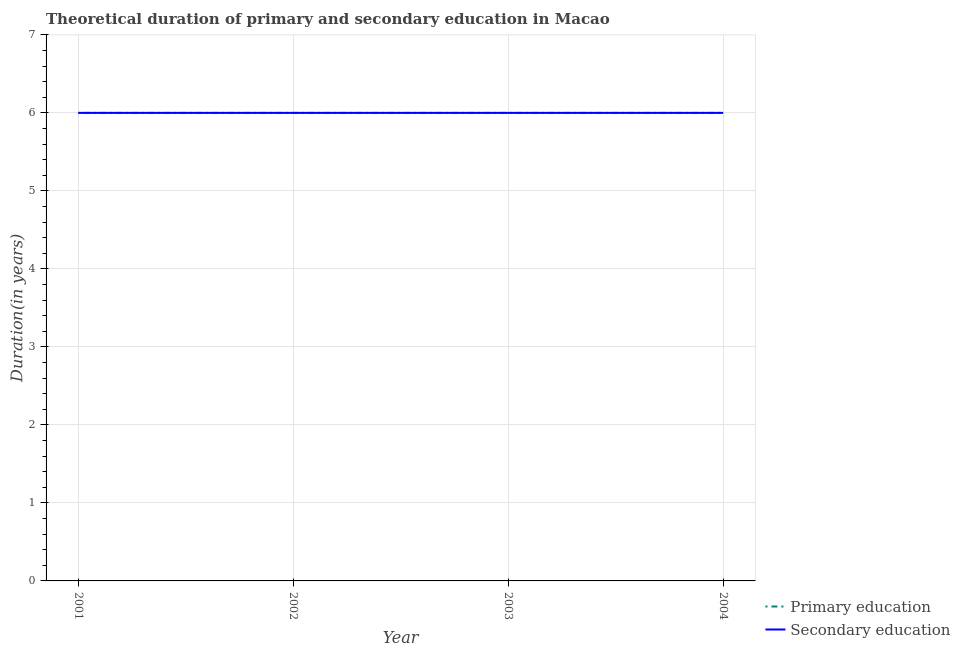How many different coloured lines are there?
Your response must be concise. 2. Does the line corresponding to duration of primary education intersect with the line corresponding to duration of secondary education?
Provide a succinct answer. Yes. What is the duration of primary education in 2003?
Ensure brevity in your answer.  6. Across all years, what is the minimum duration of primary education?
Give a very brief answer. 6. In which year was the duration of secondary education maximum?
Provide a short and direct response. 2001. What is the total duration of secondary education in the graph?
Your response must be concise. 24. What is the difference between the duration of secondary education in 2001 and that in 2003?
Make the answer very short. 0. What is the difference between the duration of primary education in 2004 and the duration of secondary education in 2001?
Offer a terse response. 0. What is the average duration of primary education per year?
Give a very brief answer. 6. In the year 2001, what is the difference between the duration of primary education and duration of secondary education?
Make the answer very short. 0. In how many years, is the duration of secondary education greater than 2.4 years?
Make the answer very short. 4. Is the duration of primary education in 2002 less than that in 2003?
Give a very brief answer. No. What is the difference between the highest and the lowest duration of secondary education?
Offer a very short reply. 0. In how many years, is the duration of secondary education greater than the average duration of secondary education taken over all years?
Your response must be concise. 0. Is the sum of the duration of secondary education in 2002 and 2003 greater than the maximum duration of primary education across all years?
Offer a very short reply. Yes. What is the difference between two consecutive major ticks on the Y-axis?
Your answer should be very brief. 1. Does the graph contain grids?
Provide a short and direct response. Yes. How many legend labels are there?
Offer a terse response. 2. What is the title of the graph?
Keep it short and to the point. Theoretical duration of primary and secondary education in Macao. What is the label or title of the Y-axis?
Give a very brief answer. Duration(in years). What is the Duration(in years) in Primary education in 2001?
Your response must be concise. 6. What is the Duration(in years) of Primary education in 2002?
Make the answer very short. 6. What is the Duration(in years) of Primary education in 2003?
Ensure brevity in your answer.  6. What is the Duration(in years) in Secondary education in 2003?
Offer a terse response. 6. What is the Duration(in years) of Primary education in 2004?
Provide a succinct answer. 6. What is the Duration(in years) of Secondary education in 2004?
Your answer should be very brief. 6. Across all years, what is the maximum Duration(in years) in Primary education?
Your answer should be very brief. 6. Across all years, what is the maximum Duration(in years) in Secondary education?
Your response must be concise. 6. What is the difference between the Duration(in years) of Primary education in 2001 and that in 2002?
Offer a very short reply. 0. What is the difference between the Duration(in years) of Primary education in 2001 and that in 2003?
Make the answer very short. 0. What is the difference between the Duration(in years) of Secondary education in 2001 and that in 2003?
Make the answer very short. 0. What is the difference between the Duration(in years) of Primary education in 2001 and that in 2004?
Offer a terse response. 0. What is the difference between the Duration(in years) of Primary education in 2002 and that in 2003?
Your answer should be very brief. 0. What is the difference between the Duration(in years) in Secondary education in 2002 and that in 2003?
Provide a succinct answer. 0. What is the difference between the Duration(in years) in Primary education in 2002 and that in 2004?
Your response must be concise. 0. What is the difference between the Duration(in years) in Secondary education in 2002 and that in 2004?
Give a very brief answer. 0. What is the difference between the Duration(in years) in Primary education in 2003 and that in 2004?
Make the answer very short. 0. What is the difference between the Duration(in years) of Secondary education in 2003 and that in 2004?
Offer a very short reply. 0. What is the difference between the Duration(in years) of Primary education in 2001 and the Duration(in years) of Secondary education in 2003?
Offer a very short reply. 0. What is the difference between the Duration(in years) in Primary education in 2001 and the Duration(in years) in Secondary education in 2004?
Provide a succinct answer. 0. What is the difference between the Duration(in years) of Primary education in 2002 and the Duration(in years) of Secondary education in 2003?
Keep it short and to the point. 0. What is the difference between the Duration(in years) of Primary education in 2002 and the Duration(in years) of Secondary education in 2004?
Ensure brevity in your answer.  0. What is the difference between the Duration(in years) in Primary education in 2003 and the Duration(in years) in Secondary education in 2004?
Your answer should be compact. 0. What is the average Duration(in years) of Primary education per year?
Offer a very short reply. 6. In the year 2002, what is the difference between the Duration(in years) in Primary education and Duration(in years) in Secondary education?
Give a very brief answer. 0. In the year 2003, what is the difference between the Duration(in years) in Primary education and Duration(in years) in Secondary education?
Your response must be concise. 0. What is the ratio of the Duration(in years) of Primary education in 2001 to that in 2004?
Provide a short and direct response. 1. What is the ratio of the Duration(in years) in Primary education in 2002 to that in 2003?
Offer a terse response. 1. What is the ratio of the Duration(in years) of Primary education in 2002 to that in 2004?
Make the answer very short. 1. What is the ratio of the Duration(in years) in Secondary education in 2003 to that in 2004?
Ensure brevity in your answer.  1. What is the difference between the highest and the lowest Duration(in years) in Secondary education?
Offer a very short reply. 0. 